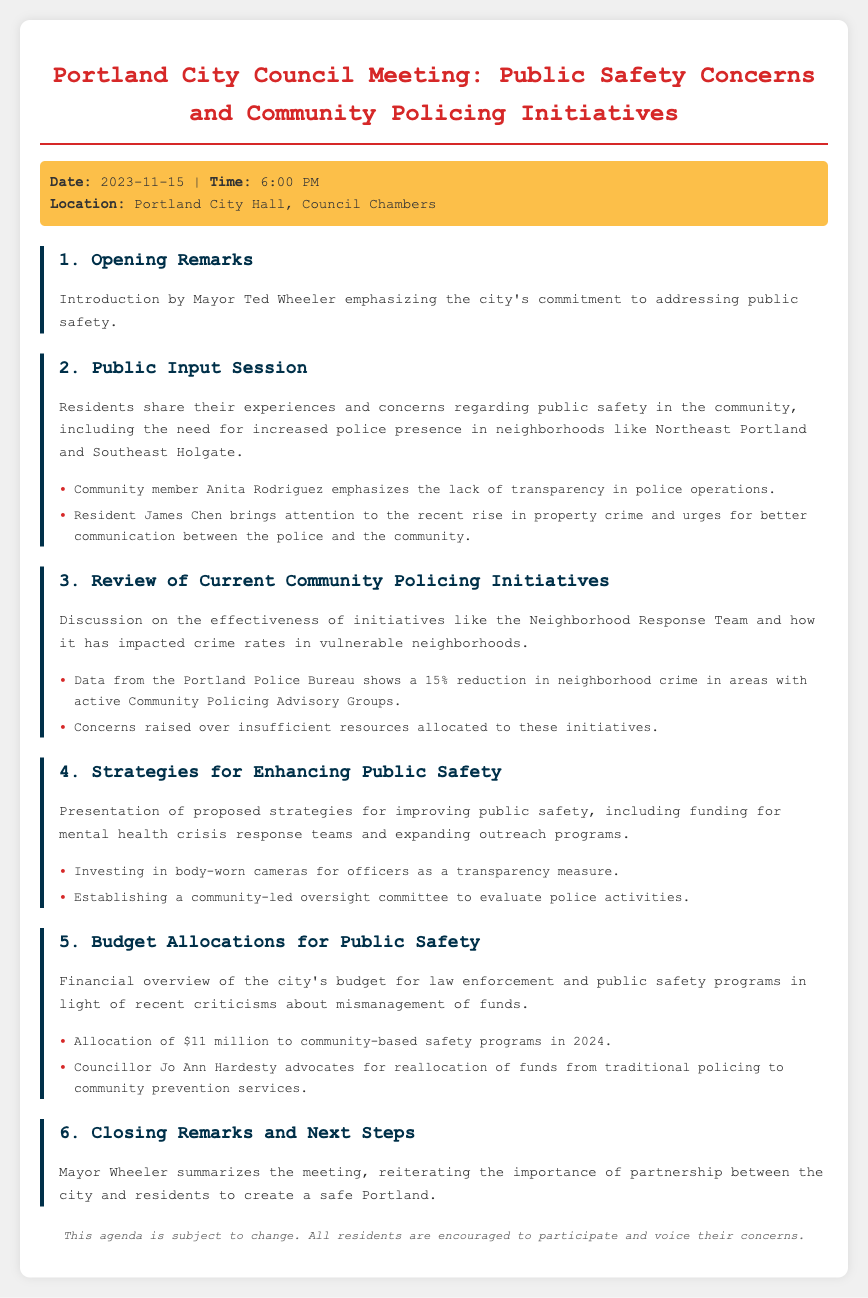What is the date of the meeting? The date of the meeting is specified in the meeting info section of the document.
Answer: 2023-11-15 Who introduced the meeting? The introduction of the meeting is mentioned in the opening remarks section, identifying the person who introduced it.
Answer: Mayor Ted Wheeler What initiative is discussed in the review of current community policing initiatives? The agenda item details the initiatives being reviewed for community policing efforts.
Answer: Neighborhood Response Team How much is allocated to community-based safety programs in 2024? The budget allocations section states the amount designated for community-based safety programs.
Answer: $11 million What is Mayor Wheeler's summarization of the meeting emphasizing? The conclusion of the agenda outlines what the mayor reiterates regarding community involvement in public safety.
Answer: Partnership between the city and residents What was a concern raised by community member Anita Rodriguez? The document lists specific concerns raised during the public input session, highlighting Anita Rodriguez's points.
Answer: Lack of transparency in police operations Which neighborhood areas are mentioned as needing increased police presence? The public input session highlights specific neighborhoods where residents feel police presence needs to increase.
Answer: Northeast Portland and Southeast Holgate Who advocated for reallocating funds from traditional policing? The advocacy for fund reallocation is mentioned in the budget allocations section, specifying who made the argument.
Answer: Councillor Jo Ann Hardesty 